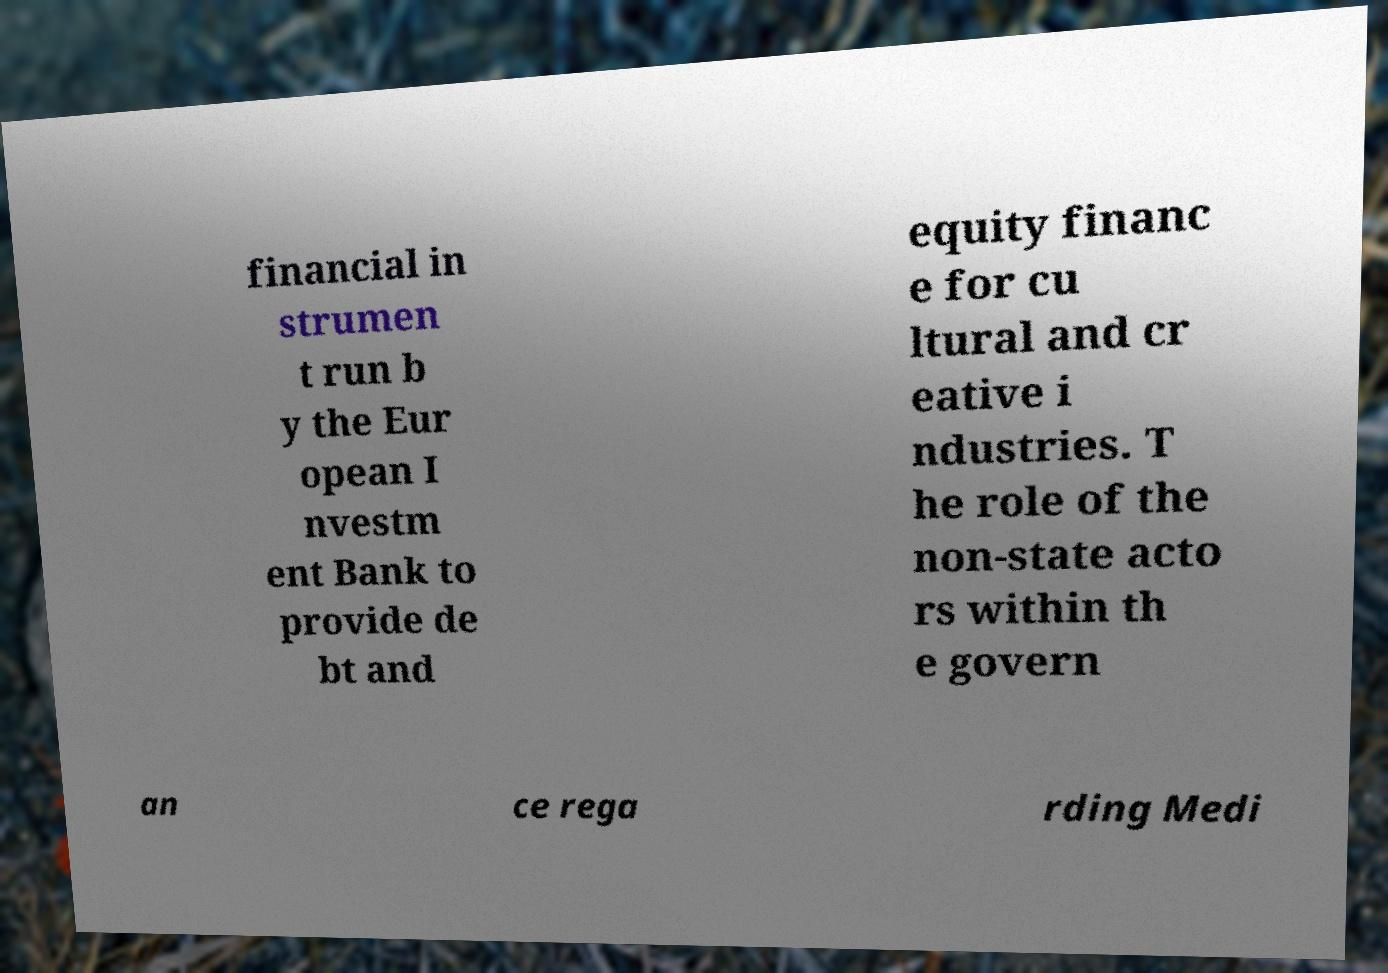Could you assist in decoding the text presented in this image and type it out clearly? financial in strumen t run b y the Eur opean I nvestm ent Bank to provide de bt and equity financ e for cu ltural and cr eative i ndustries. T he role of the non-state acto rs within th e govern an ce rega rding Medi 